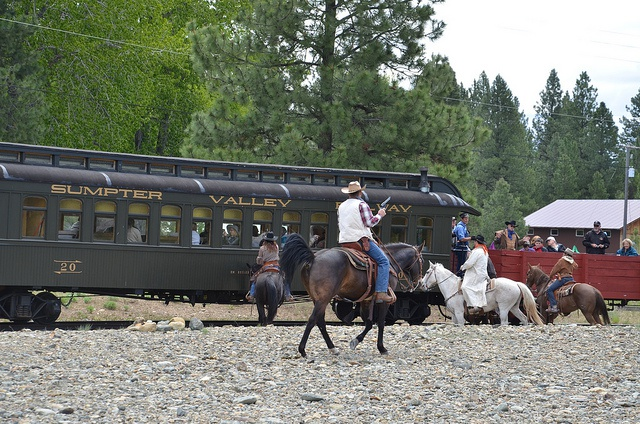Describe the objects in this image and their specific colors. I can see train in black, gray, and purple tones, horse in black, gray, and darkgray tones, horse in black, darkgray, lightgray, and gray tones, people in black, lightgray, gray, and darkgray tones, and horse in black, maroon, gray, and darkgray tones in this image. 